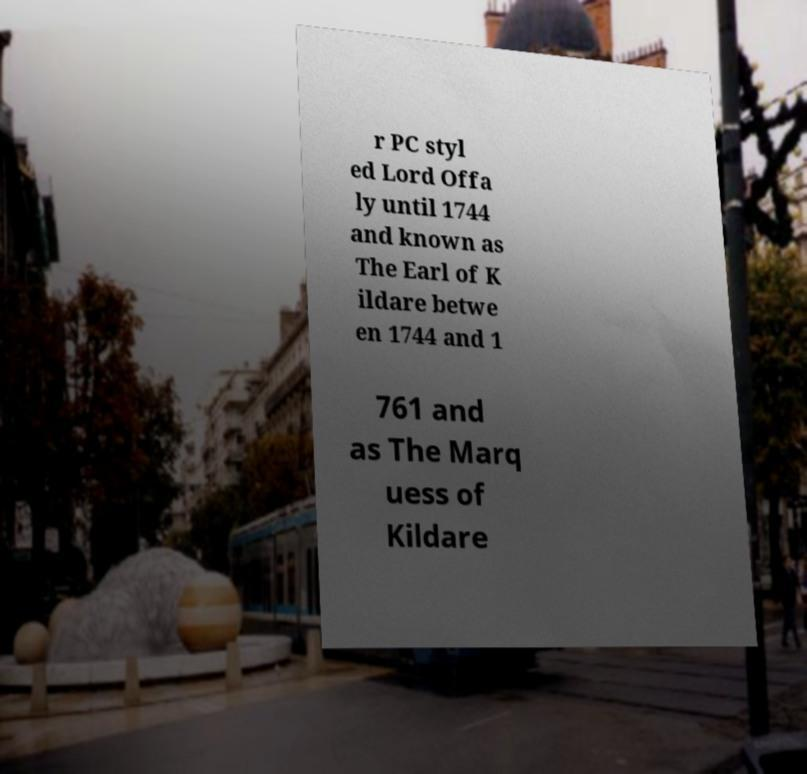For documentation purposes, I need the text within this image transcribed. Could you provide that? r PC styl ed Lord Offa ly until 1744 and known as The Earl of K ildare betwe en 1744 and 1 761 and as The Marq uess of Kildare 